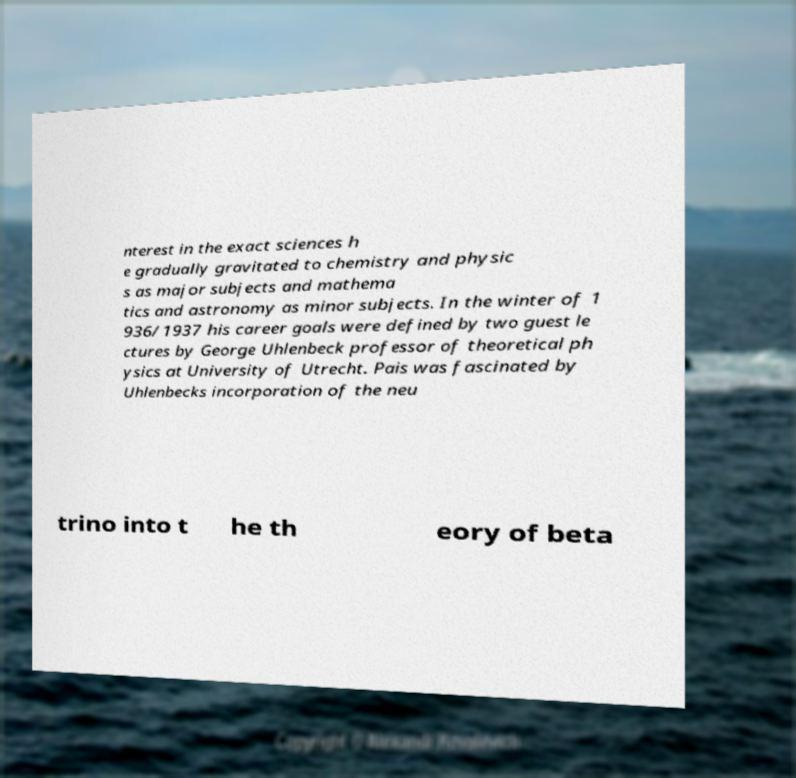What messages or text are displayed in this image? I need them in a readable, typed format. nterest in the exact sciences h e gradually gravitated to chemistry and physic s as major subjects and mathema tics and astronomy as minor subjects. In the winter of 1 936/1937 his career goals were defined by two guest le ctures by George Uhlenbeck professor of theoretical ph ysics at University of Utrecht. Pais was fascinated by Uhlenbecks incorporation of the neu trino into t he th eory of beta 